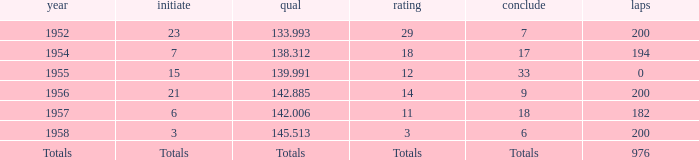What place did Jimmy Reece start from when he ranked 12? 15.0. Could you help me parse every detail presented in this table? {'header': ['year', 'initiate', 'qual', 'rating', 'conclude', 'laps'], 'rows': [['1952', '23', '133.993', '29', '7', '200'], ['1954', '7', '138.312', '18', '17', '194'], ['1955', '15', '139.991', '12', '33', '0'], ['1956', '21', '142.885', '14', '9', '200'], ['1957', '6', '142.006', '11', '18', '182'], ['1958', '3', '145.513', '3', '6', '200'], ['Totals', 'Totals', 'Totals', 'Totals', 'Totals', '976']]} 